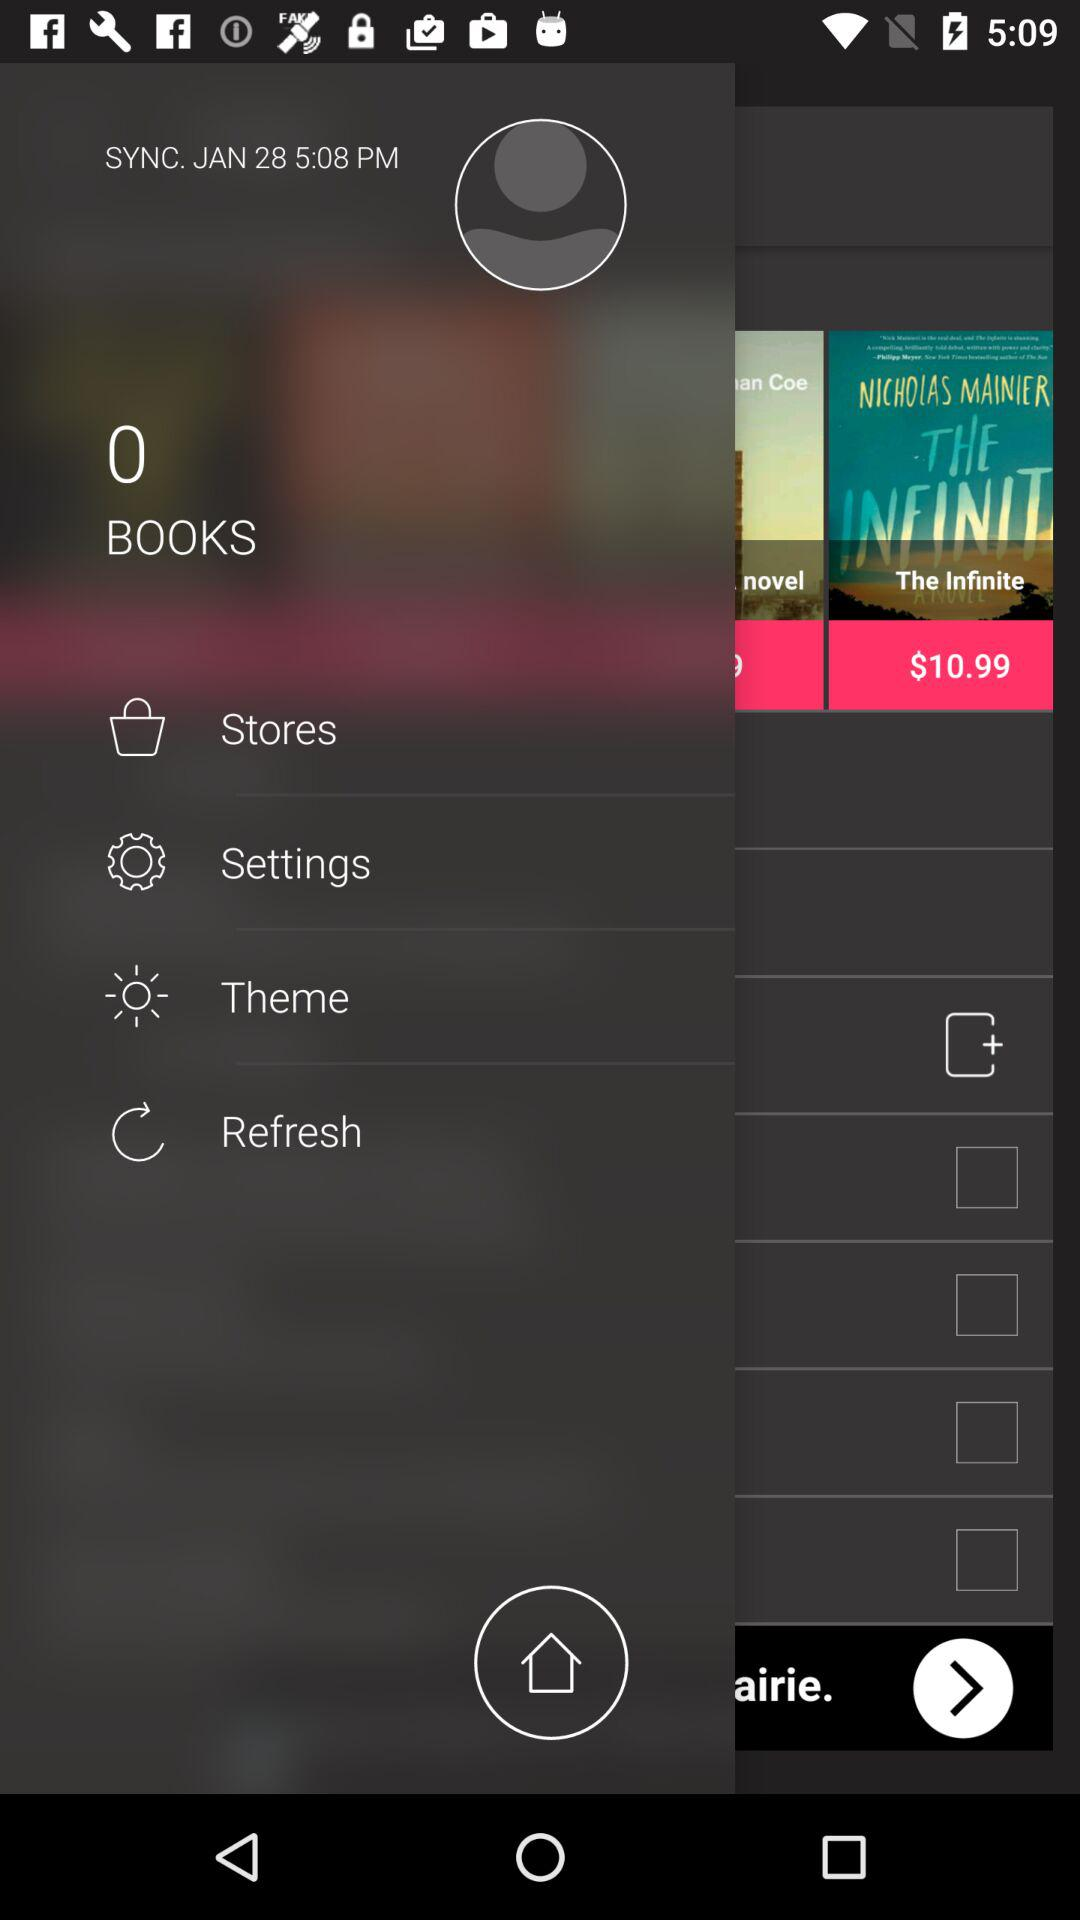What is the selected number of books? The selected number of books is 0. 